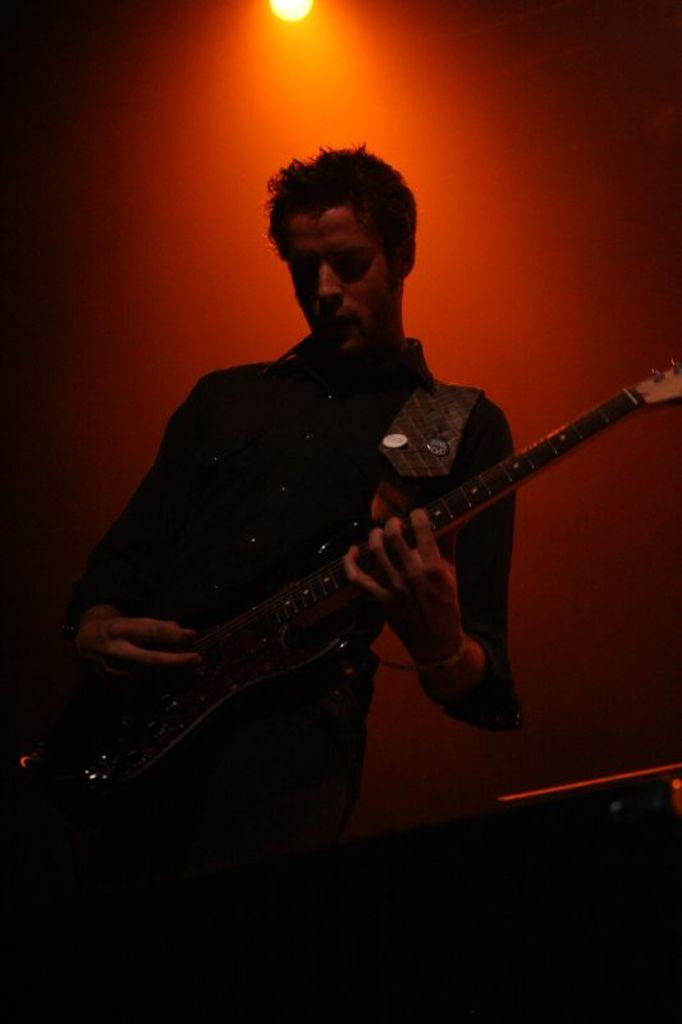What is the main subject of the image? There is a person in the image. What is the person doing in the image? The person is standing and playing a guitar. What type of error can be seen in the image? There is no error present in the image; it features a person standing and playing a guitar. Can you tell me what kind of goat is visible in the image? There is no goat present in the image. 